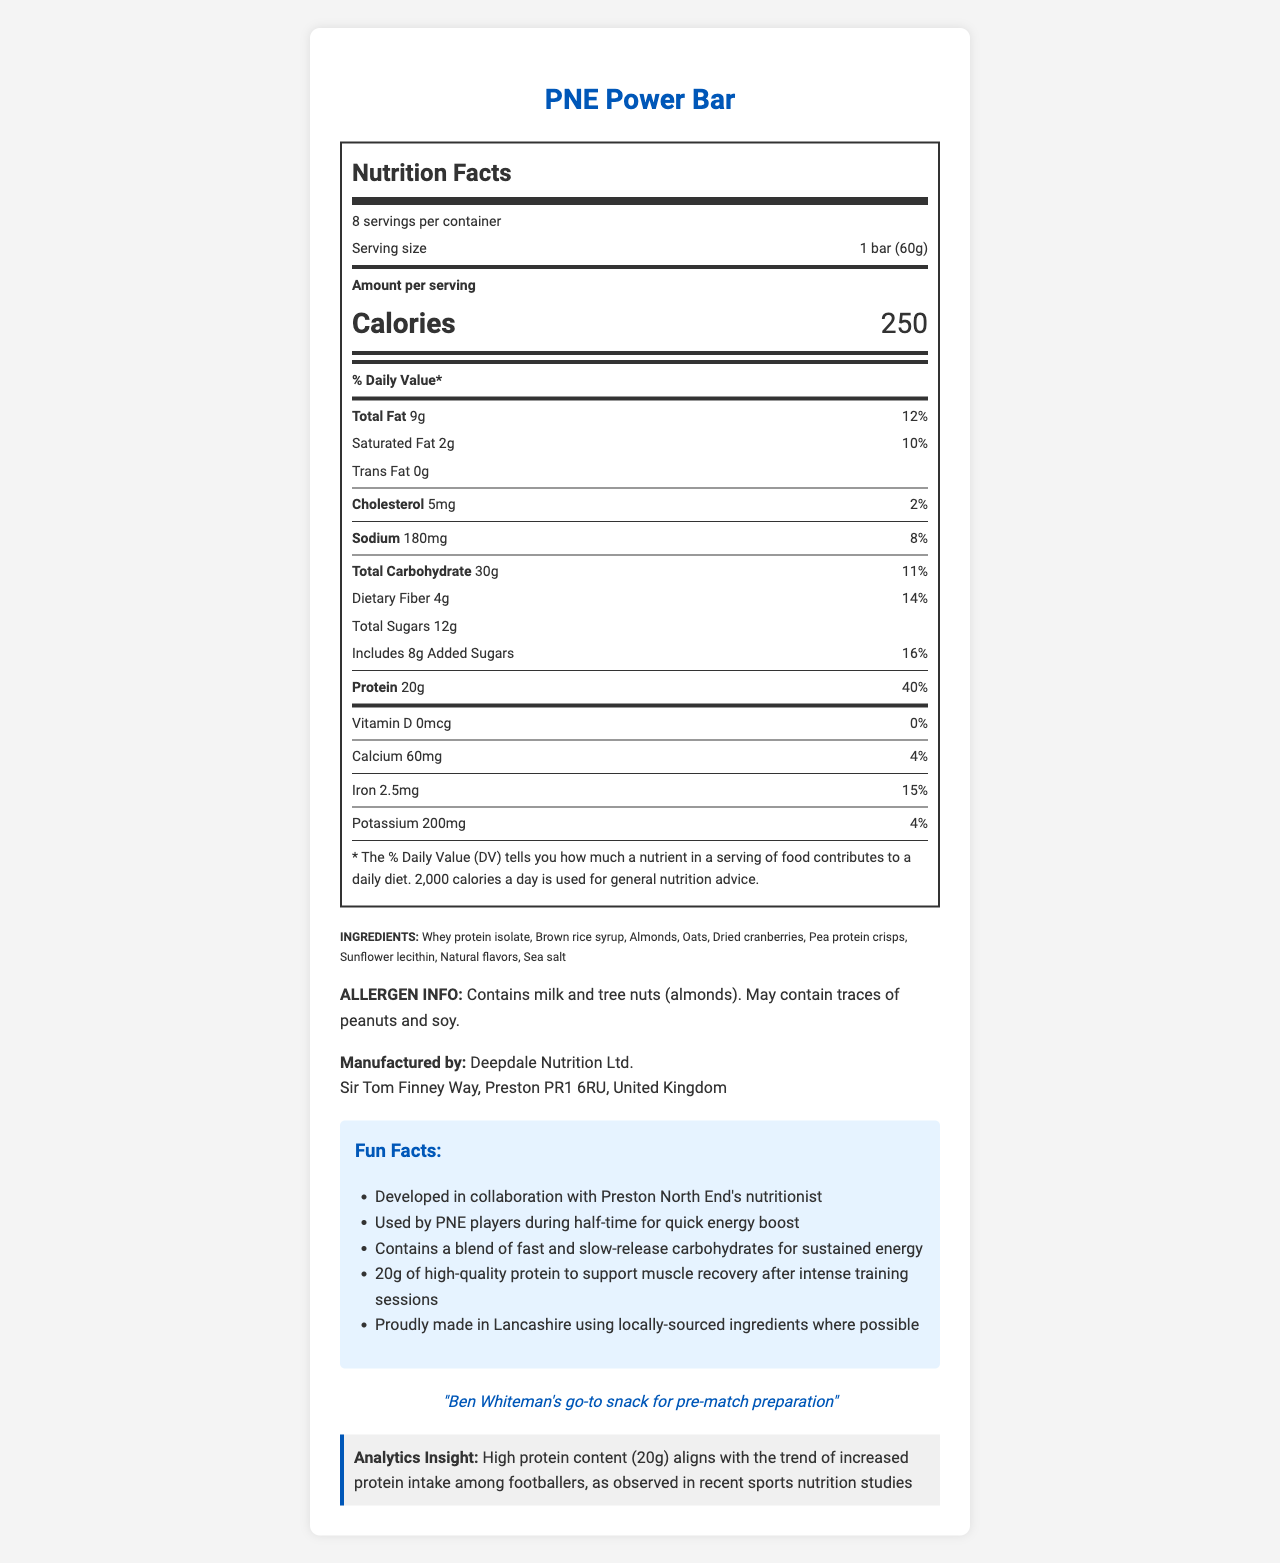what is the serving size of the PNE Power Bar? The serving size is listed as "1 bar (60g)" on the document.
Answer: 1 bar (60g) How many calories are in one serving of the PNE Power Bar? The document states that each serving contains 250 calories.
Answer: 250 What is the percentage of Daily Value (%DV) of saturated fat in the PNE Power Bar? The nutrition label shows that one bar contains 2g of saturated fat, which is 10% of the daily value.
Answer: 10% Name two types of fat listed on the PNE Power Bar nutrition label. The nutrition label lists both Saturated Fat (2g) and Trans Fat (0g).
Answer: Saturated Fat and Trans Fat How much protein is in one bar of the PNE Power Bar? The document indicates that each serving includes 20g of protein.
Answer: 20g Which of the following is an ingredient in the PNE Power Bar? A. Soy Protein Isolate B. Brown Rice Syrup C. Corn Syrup The list of ingredients includes "Brown Rice Syrup."
Answer: B What is the serving size and the number of servings per container for the PNE Power Bar? The document lists the serving size as 1 bar (60g) and indicates there are 8 servings per container.
Answer: 1 bar (60g), 8 servings per container What is the % Daily Value for dietary fiber in the PNE Power Bar? The nutrition label states that the bar contains 4g of dietary fiber, which contributes 14% to the daily value.
Answer: 14% Is the PNE Power Bar endorsed by a player? A. Yes, Ben Whiteman B. No C. Yes, Tom Barkhuizen D. Cannot be determined The document notes an endorsement from Ben Whiteman.
Answer: A What are the potential allergens listed for the PNE Power Bar? The allergen information section mentions these specific allergens.
Answer: Milk, tree nuts (almonds), traces of peanuts, and soy Is the PNE Power Bar manufacturer based in the United Kingdom? The manufacturer's address is listed as "Sir Tom Finney Way, Preston PR1 6RU, United Kingdom," indicating a UK location.
Answer: Yes What nutritional insight related to protein intake is mentioned? The analytics section mentions that high protein content (20g) aligns with this trend.
Answer: Recent sports nutrition studies trend towards increased protein intake among footballers. Describe the overall information provided in the PNE Power Bar document. The document comprehensively covers multiple aspects: nutritional content, ingredients, allergens, manufacturer details, promotional elements, and an analytical insight related to protein intake in sports.
Answer: The document includes the nutritional facts, ingredient list, allergen information, manufacturer details, fun facts, player endorsement, and an analytics insight about the protein content of the PNE Power Bar, which is specially designed for Preston North End players. What is the exact amount of potassium in a serving of the PNE Power Bar? The document indicates that each serving contains 200mg of potassium.
Answer: 200mg Is there any information about how the PNE Power Bar should be stored? The document does not provide any storage instructions.
Answer: Not enough information What is the % Daily Value for calcium in one serving of the PNE Power Bar? The nutrition label shows that one serving contains 60mg of calcium, contributing 4% to the daily value.
Answer: 4% What is the percentage of added sugars in one serving of the PNE Power Bar? A. 16% B. 12% C. 14% The document states that the bar includes 8g of added sugars, which is 16% of the daily value.
Answer: A 